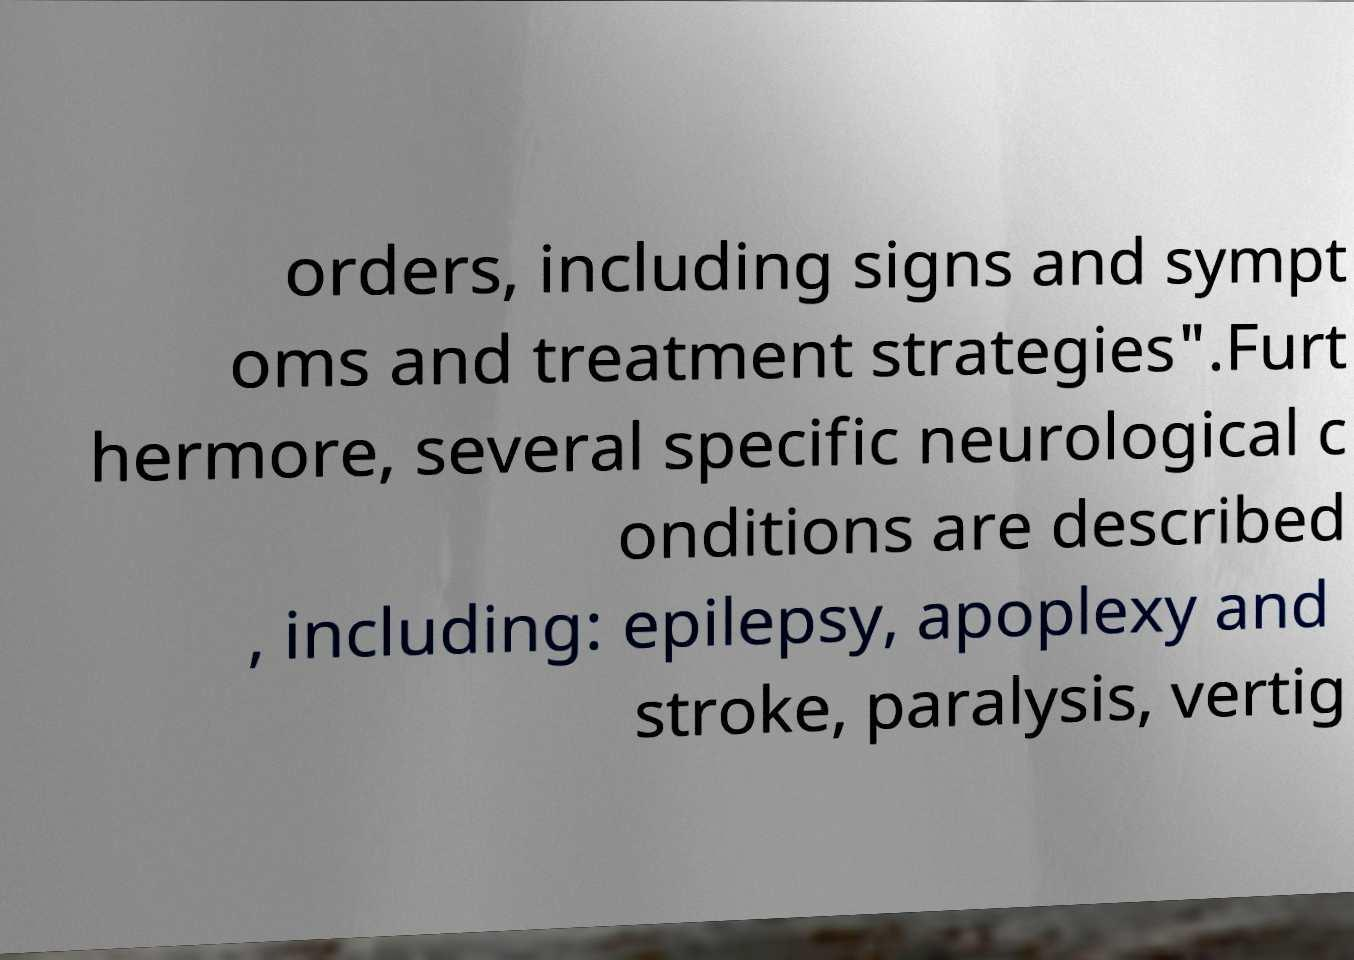Could you extract and type out the text from this image? orders, including signs and sympt oms and treatment strategies".Furt hermore, several specific neurological c onditions are described , including: epilepsy, apoplexy and stroke, paralysis, vertig 